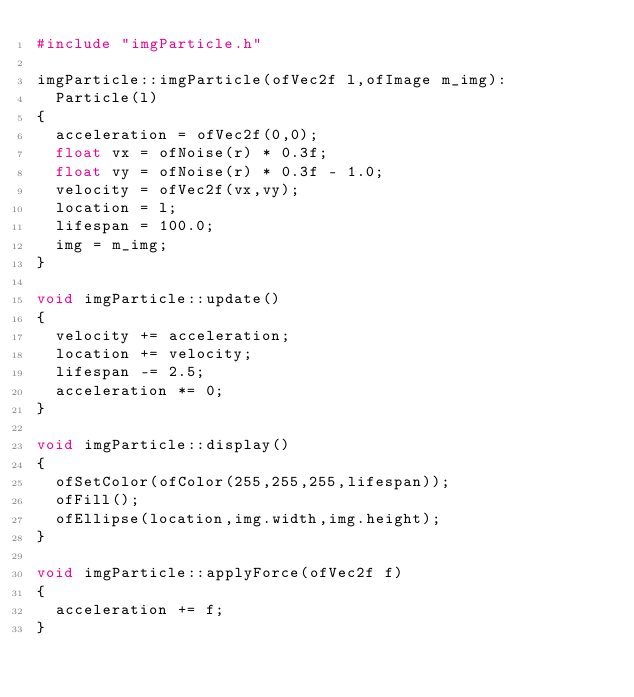<code> <loc_0><loc_0><loc_500><loc_500><_C++_>#include "imgParticle.h"

imgParticle::imgParticle(ofVec2f l,ofImage m_img):
	Particle(l)
{
	acceleration = ofVec2f(0,0);
	float vx = ofNoise(r) * 0.3f;
	float vy = ofNoise(r) * 0.3f - 1.0;
	velocity = ofVec2f(vx,vy);
	location = l;
	lifespan = 100.0;
	img = m_img;
}

void imgParticle::update()
{
	velocity += acceleration;
	location += velocity;
	lifespan -= 2.5;
	acceleration *= 0;
}

void imgParticle::display()
{
	ofSetColor(ofColor(255,255,255,lifespan));
	ofFill();
	ofEllipse(location,img.width,img.height);
}

void imgParticle::applyForce(ofVec2f f)
{
	acceleration += f;
}</code> 